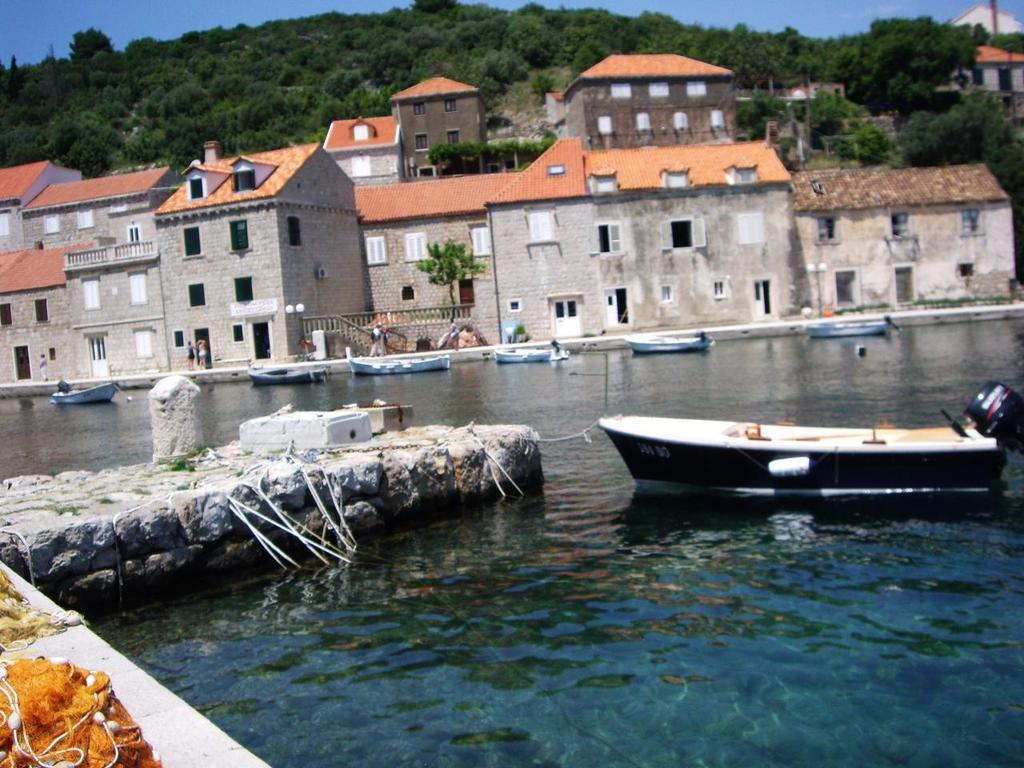What type of structures can be seen in the image? There are buildings in the image. What is located at the bottom of the image? There is water at the bottom of the image. What is floating on the water in the image? Boats are visible on the water. What can be seen in the background of the image? There are trees, a hill, and the sky visible in the background of the image. Where are the dolls playing in the image? There are no dolls present in the image. What type of bushes can be seen growing near the water in the image? There are no bushes visible in the image; it features buildings, water, boats, trees, a hill, and the sky. 